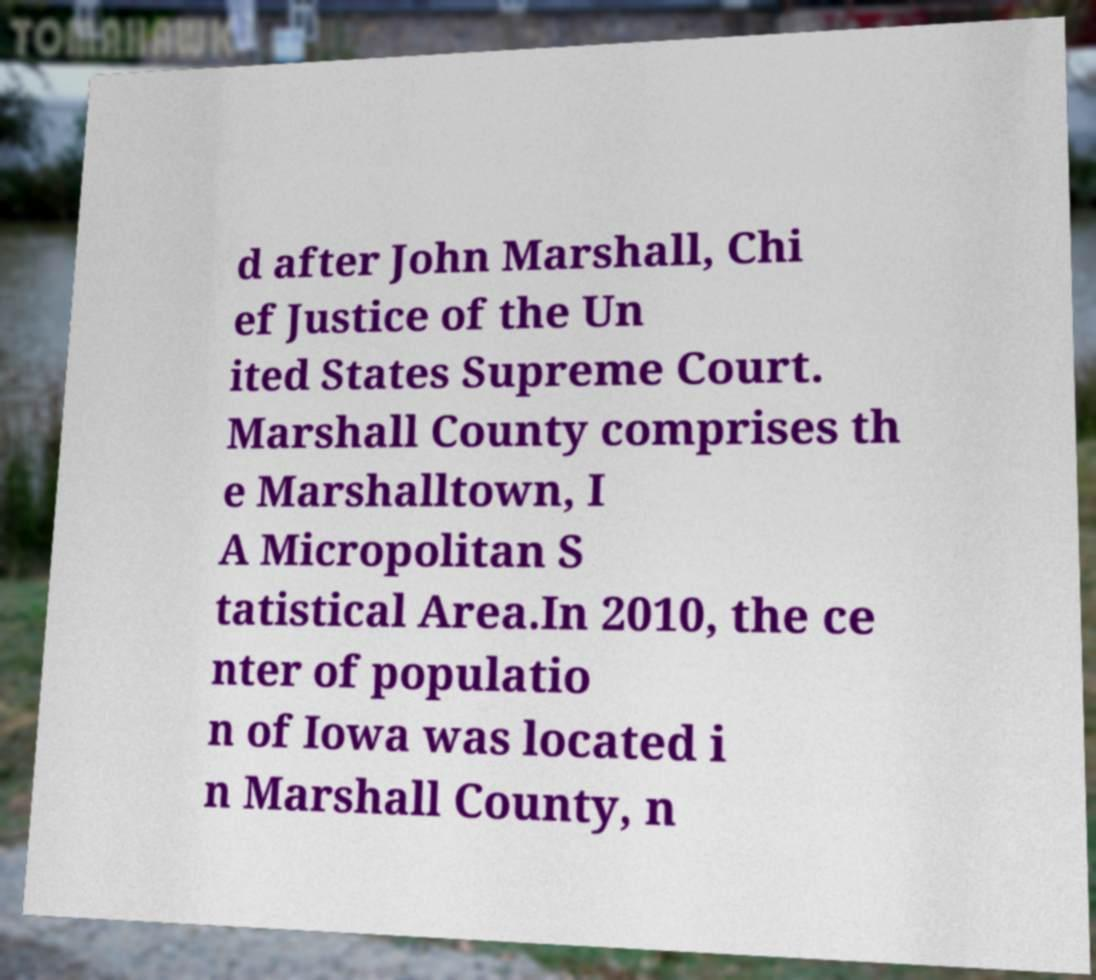Please identify and transcribe the text found in this image. d after John Marshall, Chi ef Justice of the Un ited States Supreme Court. Marshall County comprises th e Marshalltown, I A Micropolitan S tatistical Area.In 2010, the ce nter of populatio n of Iowa was located i n Marshall County, n 